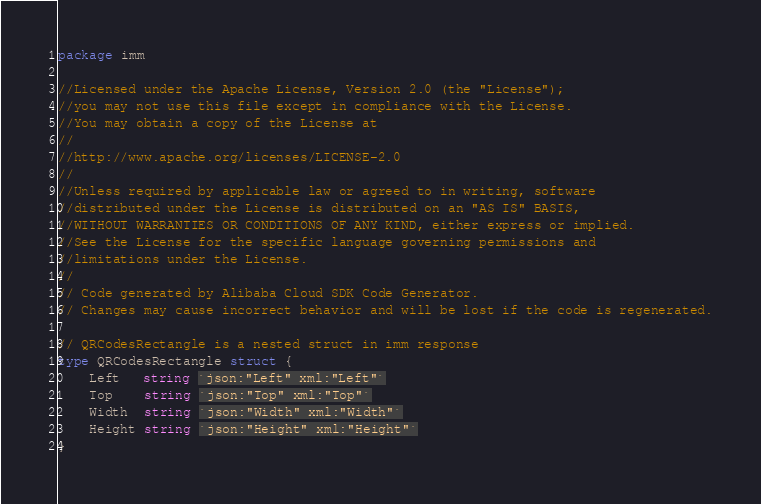<code> <loc_0><loc_0><loc_500><loc_500><_Go_>package imm

//Licensed under the Apache License, Version 2.0 (the "License");
//you may not use this file except in compliance with the License.
//You may obtain a copy of the License at
//
//http://www.apache.org/licenses/LICENSE-2.0
//
//Unless required by applicable law or agreed to in writing, software
//distributed under the License is distributed on an "AS IS" BASIS,
//WITHOUT WARRANTIES OR CONDITIONS OF ANY KIND, either express or implied.
//See the License for the specific language governing permissions and
//limitations under the License.
//
// Code generated by Alibaba Cloud SDK Code Generator.
// Changes may cause incorrect behavior and will be lost if the code is regenerated.

// QRCodesRectangle is a nested struct in imm response
type QRCodesRectangle struct {
	Left   string `json:"Left" xml:"Left"`
	Top    string `json:"Top" xml:"Top"`
	Width  string `json:"Width" xml:"Width"`
	Height string `json:"Height" xml:"Height"`
}
</code> 